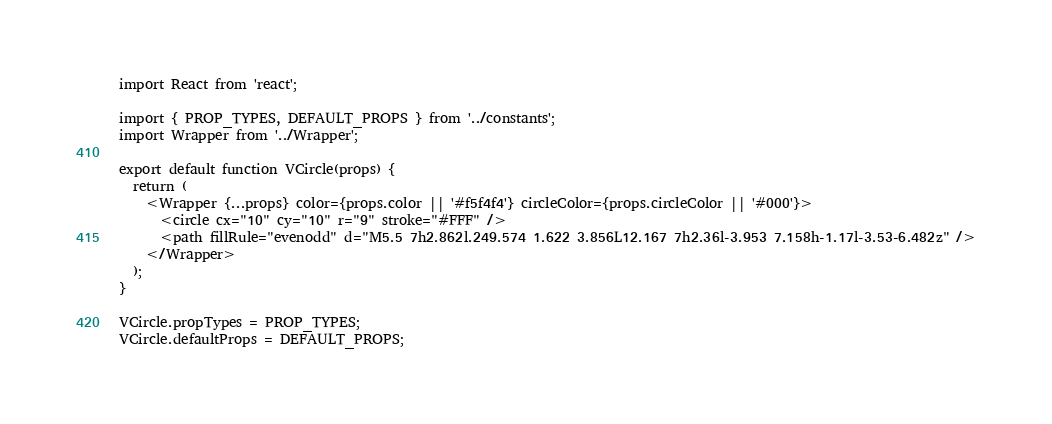Convert code to text. <code><loc_0><loc_0><loc_500><loc_500><_JavaScript_>import React from 'react';

import { PROP_TYPES, DEFAULT_PROPS } from '../constants';
import Wrapper from '../Wrapper';

export default function VCircle(props) {
  return (
    <Wrapper {...props} color={props.color || '#f5f4f4'} circleColor={props.circleColor || '#000'}>
      <circle cx="10" cy="10" r="9" stroke="#FFF" />
      <path fillRule="evenodd" d="M5.5 7h2.862l.249.574 1.622 3.856L12.167 7h2.36l-3.953 7.158h-1.17l-3.53-6.482z" />
    </Wrapper>
  );
}

VCircle.propTypes = PROP_TYPES;
VCircle.defaultProps = DEFAULT_PROPS;
</code> 